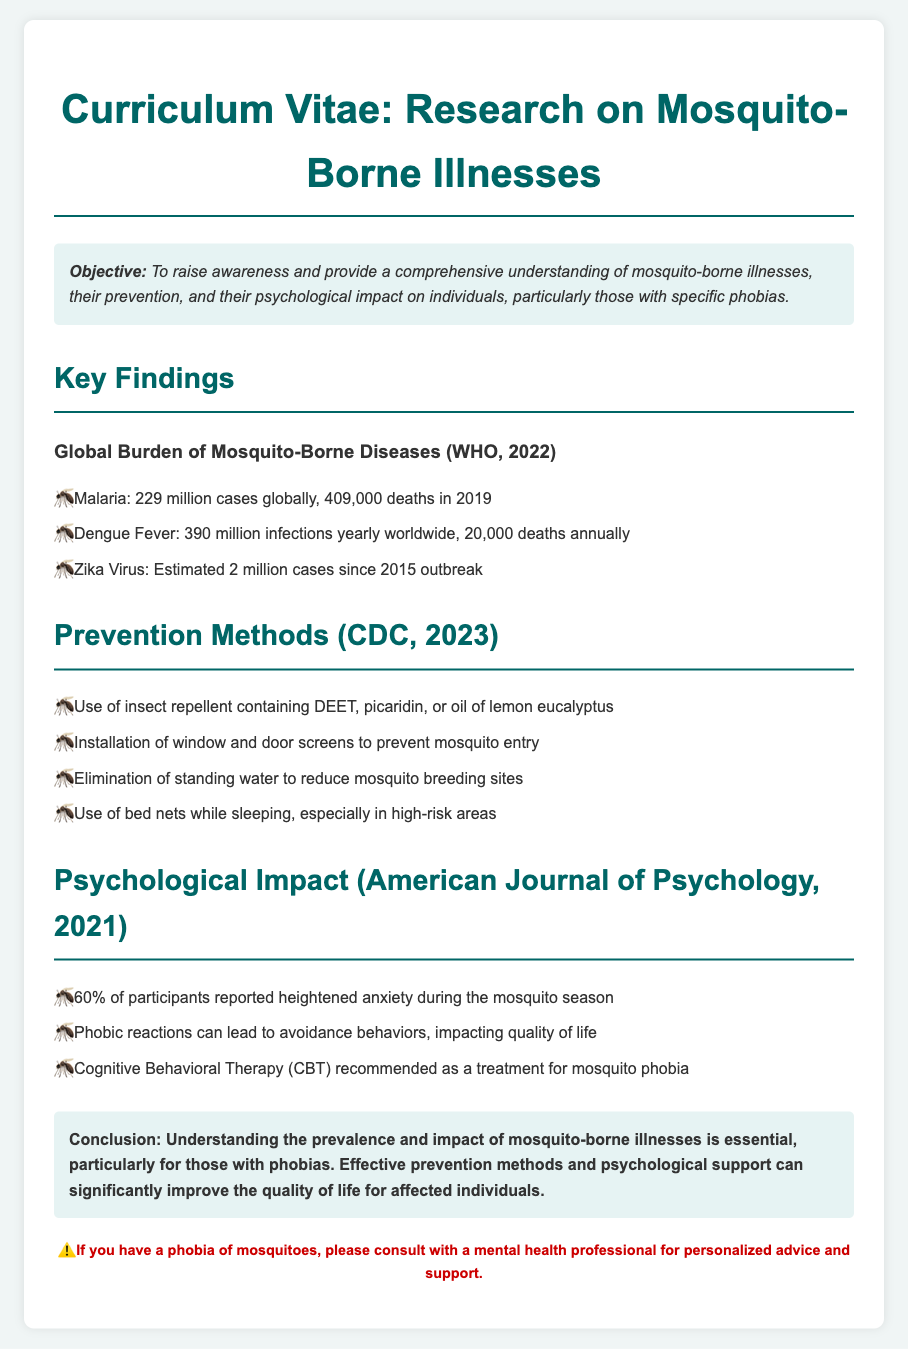What is the primary objective of the research? The objective outlined in the document is to raise awareness and provide understanding of mosquito-borne illnesses and their impact, particularly for individuals with phobias.
Answer: To raise awareness and provide a comprehensive understanding of mosquito-borne illnesses, their prevention, and their psychological impact on individuals, particularly those with specific phobias How many cases of malaria were there globally in 2019? The document states that there were 229 million cases of malaria globally in 2019.
Answer: 229 million cases What prevention method is suggested for reducing mosquito breeding sites? The document mentions that eliminating standing water is a recommended method for reducing mosquito breeding sites.
Answer: Elimination of standing water What percentage of participants reported heightened anxiety during mosquito season? The document indicated that 60% of participants reported heightened anxiety during mosquito season.
Answer: 60% Which type of therapy is recommended for mosquito phobia? According to the document, Cognitive Behavioral Therapy (CBT) is recommended as a treatment for mosquito phobia.
Answer: Cognitive Behavioral Therapy (CBT) What statistic is provided about dengue fever's annual deaths? The document states that there are about 20,000 deaths annually due to dengue fever.
Answer: 20,000 deaths annually What year is cited for the estimated 2 million cases of the Zika virus? The document indicates that the estimated 2 million cases of Zika virus occurred since the 2015 outbreak.
Answer: 2015 What type of document is presented? The context and structure of the document indicate that it is a Curriculum Vitae focusing on research about mosquito-borne illnesses.
Answer: Curriculum Vitae 